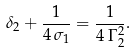<formula> <loc_0><loc_0><loc_500><loc_500>\delta _ { 2 } + \frac { 1 } { 4 \, \sigma _ { 1 } } = \frac { 1 } { 4 \, \Gamma _ { 2 } ^ { 2 } } .</formula> 